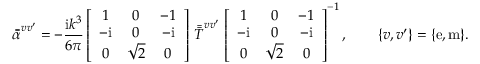Convert formula to latex. <formula><loc_0><loc_0><loc_500><loc_500>\bar { \bar { \alpha } } ^ { v v ^ { \prime } } = - \frac { i k ^ { 3 } } { 6 \pi } \left [ \begin{array} { c c c } { 1 } & { 0 } & { - 1 } \\ { - i } & { 0 } & { - i } \\ { 0 } & { \sqrt { 2 } } & { 0 } \end{array} \right ] \, \bar { \bar { T } } ^ { v v ^ { \prime } } \, \left [ \begin{array} { c c c } { 1 } & { 0 } & { - 1 } \\ { - i } & { 0 } & { - i } \\ { 0 } & { \sqrt { 2 } } & { 0 } \end{array} \right ] ^ { - 1 } , \quad \{ v , v ^ { \prime } \} = \{ e , m \} .</formula> 